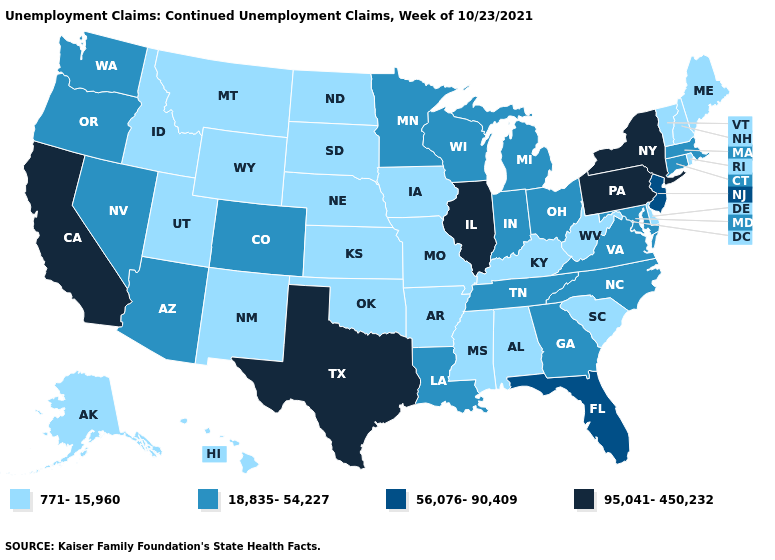Does Mississippi have the same value as Tennessee?
Concise answer only. No. Which states have the lowest value in the USA?
Answer briefly. Alabama, Alaska, Arkansas, Delaware, Hawaii, Idaho, Iowa, Kansas, Kentucky, Maine, Mississippi, Missouri, Montana, Nebraska, New Hampshire, New Mexico, North Dakota, Oklahoma, Rhode Island, South Carolina, South Dakota, Utah, Vermont, West Virginia, Wyoming. What is the value of Ohio?
Quick response, please. 18,835-54,227. What is the value of Arizona?
Short answer required. 18,835-54,227. How many symbols are there in the legend?
Keep it brief. 4. Which states have the lowest value in the USA?
Be succinct. Alabama, Alaska, Arkansas, Delaware, Hawaii, Idaho, Iowa, Kansas, Kentucky, Maine, Mississippi, Missouri, Montana, Nebraska, New Hampshire, New Mexico, North Dakota, Oklahoma, Rhode Island, South Carolina, South Dakota, Utah, Vermont, West Virginia, Wyoming. What is the value of Rhode Island?
Write a very short answer. 771-15,960. Name the states that have a value in the range 95,041-450,232?
Write a very short answer. California, Illinois, New York, Pennsylvania, Texas. What is the value of Idaho?
Be succinct. 771-15,960. What is the value of North Carolina?
Concise answer only. 18,835-54,227. What is the value of Arkansas?
Concise answer only. 771-15,960. Which states have the highest value in the USA?
Answer briefly. California, Illinois, New York, Pennsylvania, Texas. Does Maine have the lowest value in the Northeast?
Give a very brief answer. Yes. Does the first symbol in the legend represent the smallest category?
Quick response, please. Yes. What is the value of Texas?
Be succinct. 95,041-450,232. 